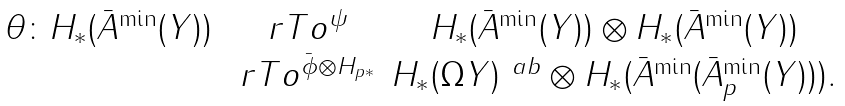Convert formula to latex. <formula><loc_0><loc_0><loc_500><loc_500>\begin{array} { c c c } \theta \colon H _ { * } ( \bar { A } ^ { \min } ( Y ) ) & \ r T o ^ { \psi } & H _ { * } ( \bar { A } ^ { \min } ( Y ) ) \otimes H _ { * } ( \bar { A } ^ { \min } ( Y ) ) \\ & \ r T o ^ { \bar { \phi } \otimes H _ { p \ast } } & H _ { * } ( \Omega Y ) ^ { \ a b } \otimes H _ { * } ( \bar { A } ^ { \min } ( \bar { A } ^ { \min } _ { p } ( Y ) ) ) . \\ \end{array}</formula> 